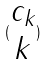Convert formula to latex. <formula><loc_0><loc_0><loc_500><loc_500>( \begin{matrix} c _ { k } \\ k \end{matrix} )</formula> 